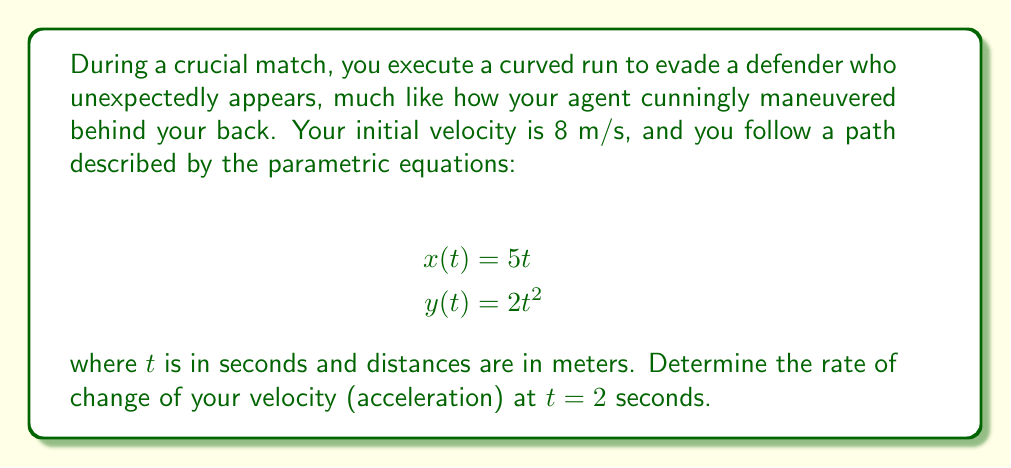Can you answer this question? To solve this problem, we'll follow these steps:

1) First, we need to find the velocity vector. The velocity is the derivative of the position vector with respect to time:

   $\vec{v}(t) = (\frac{dx}{dt}, \frac{dy}{dt}) = (5, 4t)$

2) Now, we need to find the magnitude of the velocity vector:

   $|\vec{v}(t)| = \sqrt{(\frac{dx}{dt})^2 + (\frac{dy}{dt})^2} = \sqrt{5^2 + (4t)^2} = \sqrt{25 + 16t^2}$

3) The acceleration vector is the derivative of the velocity vector:

   $\vec{a}(t) = (\frac{d^2x}{dt^2}, \frac{d^2y}{dt^2}) = (0, 4)$

4) However, we're asked for the rate of change of velocity (acceleration) at $t = 2$. This isn't simply the magnitude of the acceleration vector, because the direction of motion is constantly changing due to the curved path.

5) To find the correct acceleration, we need to use the formula:

   $a = \frac{d}{dt}|\vec{v}(t)|$

6) Let's calculate this:

   $\frac{d}{dt}|\vec{v}(t)| = \frac{d}{dt}\sqrt{25 + 16t^2}$
   
   $= \frac{1}{2}(25 + 16t^2)^{-1/2} \cdot 32t$
   
   $= \frac{16t}{\sqrt{25 + 16t^2}}$

7) Now, we can plug in $t = 2$:

   $a(2) = \frac{16 \cdot 2}{\sqrt{25 + 16 \cdot 2^2}} = \frac{32}{\sqrt{89}} \approx 3.39$ m/s²

This acceleration represents how quickly your speed is changing as you navigate the curved path, much like how you're now navigating the unexpected turns in your career.
Answer: The rate of change of velocity (acceleration) at $t = 2$ seconds is $\frac{32}{\sqrt{89}} \approx 3.39$ m/s². 